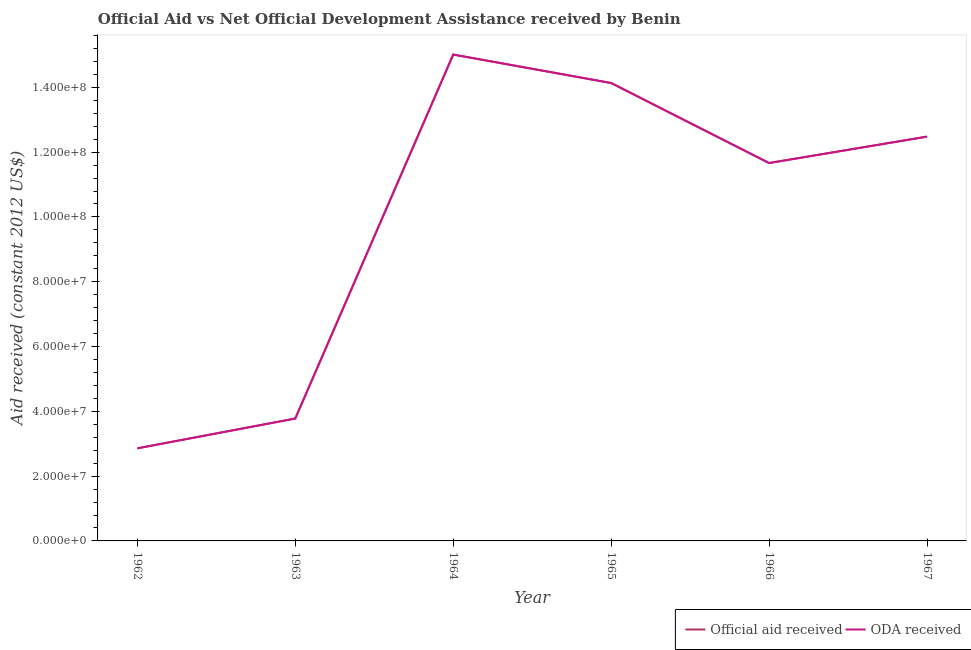What is the oda received in 1962?
Provide a succinct answer. 2.86e+07. Across all years, what is the maximum oda received?
Offer a terse response. 1.50e+08. Across all years, what is the minimum official aid received?
Your answer should be compact. 2.86e+07. In which year was the official aid received maximum?
Give a very brief answer. 1964. In which year was the oda received minimum?
Provide a short and direct response. 1962. What is the total oda received in the graph?
Provide a short and direct response. 5.99e+08. What is the difference between the official aid received in 1962 and that in 1965?
Provide a succinct answer. -1.13e+08. What is the difference between the oda received in 1964 and the official aid received in 1962?
Give a very brief answer. 1.22e+08. What is the average official aid received per year?
Offer a very short reply. 9.99e+07. In the year 1962, what is the difference between the official aid received and oda received?
Ensure brevity in your answer.  0. In how many years, is the oda received greater than 60000000 US$?
Give a very brief answer. 4. What is the ratio of the official aid received in 1964 to that in 1966?
Provide a short and direct response. 1.29. Is the difference between the oda received in 1963 and 1966 greater than the difference between the official aid received in 1963 and 1966?
Offer a terse response. No. What is the difference between the highest and the second highest oda received?
Make the answer very short. 8.78e+06. What is the difference between the highest and the lowest oda received?
Keep it short and to the point. 1.22e+08. In how many years, is the official aid received greater than the average official aid received taken over all years?
Offer a very short reply. 4. Is the sum of the oda received in 1964 and 1965 greater than the maximum official aid received across all years?
Make the answer very short. Yes. How many lines are there?
Keep it short and to the point. 2. What is the difference between two consecutive major ticks on the Y-axis?
Your answer should be compact. 2.00e+07. Does the graph contain grids?
Provide a short and direct response. No. What is the title of the graph?
Offer a very short reply. Official Aid vs Net Official Development Assistance received by Benin . Does "Canada" appear as one of the legend labels in the graph?
Make the answer very short. No. What is the label or title of the Y-axis?
Offer a very short reply. Aid received (constant 2012 US$). What is the Aid received (constant 2012 US$) of Official aid received in 1962?
Your response must be concise. 2.86e+07. What is the Aid received (constant 2012 US$) in ODA received in 1962?
Make the answer very short. 2.86e+07. What is the Aid received (constant 2012 US$) of Official aid received in 1963?
Provide a short and direct response. 3.78e+07. What is the Aid received (constant 2012 US$) in ODA received in 1963?
Keep it short and to the point. 3.78e+07. What is the Aid received (constant 2012 US$) in Official aid received in 1964?
Offer a very short reply. 1.50e+08. What is the Aid received (constant 2012 US$) in ODA received in 1964?
Ensure brevity in your answer.  1.50e+08. What is the Aid received (constant 2012 US$) of Official aid received in 1965?
Your answer should be compact. 1.41e+08. What is the Aid received (constant 2012 US$) of ODA received in 1965?
Your answer should be compact. 1.41e+08. What is the Aid received (constant 2012 US$) of Official aid received in 1966?
Your answer should be very brief. 1.17e+08. What is the Aid received (constant 2012 US$) in ODA received in 1966?
Provide a short and direct response. 1.17e+08. What is the Aid received (constant 2012 US$) in Official aid received in 1967?
Keep it short and to the point. 1.25e+08. What is the Aid received (constant 2012 US$) in ODA received in 1967?
Your response must be concise. 1.25e+08. Across all years, what is the maximum Aid received (constant 2012 US$) of Official aid received?
Your answer should be very brief. 1.50e+08. Across all years, what is the maximum Aid received (constant 2012 US$) of ODA received?
Offer a terse response. 1.50e+08. Across all years, what is the minimum Aid received (constant 2012 US$) in Official aid received?
Your answer should be very brief. 2.86e+07. Across all years, what is the minimum Aid received (constant 2012 US$) in ODA received?
Offer a terse response. 2.86e+07. What is the total Aid received (constant 2012 US$) in Official aid received in the graph?
Give a very brief answer. 5.99e+08. What is the total Aid received (constant 2012 US$) in ODA received in the graph?
Provide a short and direct response. 5.99e+08. What is the difference between the Aid received (constant 2012 US$) in Official aid received in 1962 and that in 1963?
Your answer should be compact. -9.20e+06. What is the difference between the Aid received (constant 2012 US$) of ODA received in 1962 and that in 1963?
Your answer should be compact. -9.20e+06. What is the difference between the Aid received (constant 2012 US$) of Official aid received in 1962 and that in 1964?
Provide a short and direct response. -1.22e+08. What is the difference between the Aid received (constant 2012 US$) in ODA received in 1962 and that in 1964?
Keep it short and to the point. -1.22e+08. What is the difference between the Aid received (constant 2012 US$) in Official aid received in 1962 and that in 1965?
Ensure brevity in your answer.  -1.13e+08. What is the difference between the Aid received (constant 2012 US$) in ODA received in 1962 and that in 1965?
Provide a short and direct response. -1.13e+08. What is the difference between the Aid received (constant 2012 US$) of Official aid received in 1962 and that in 1966?
Your response must be concise. -8.81e+07. What is the difference between the Aid received (constant 2012 US$) of ODA received in 1962 and that in 1966?
Your answer should be very brief. -8.81e+07. What is the difference between the Aid received (constant 2012 US$) in Official aid received in 1962 and that in 1967?
Keep it short and to the point. -9.62e+07. What is the difference between the Aid received (constant 2012 US$) in ODA received in 1962 and that in 1967?
Your response must be concise. -9.62e+07. What is the difference between the Aid received (constant 2012 US$) of Official aid received in 1963 and that in 1964?
Ensure brevity in your answer.  -1.12e+08. What is the difference between the Aid received (constant 2012 US$) in ODA received in 1963 and that in 1964?
Your response must be concise. -1.12e+08. What is the difference between the Aid received (constant 2012 US$) of Official aid received in 1963 and that in 1965?
Your answer should be very brief. -1.04e+08. What is the difference between the Aid received (constant 2012 US$) of ODA received in 1963 and that in 1965?
Give a very brief answer. -1.04e+08. What is the difference between the Aid received (constant 2012 US$) of Official aid received in 1963 and that in 1966?
Offer a very short reply. -7.89e+07. What is the difference between the Aid received (constant 2012 US$) in ODA received in 1963 and that in 1966?
Your answer should be very brief. -7.89e+07. What is the difference between the Aid received (constant 2012 US$) of Official aid received in 1963 and that in 1967?
Your answer should be very brief. -8.70e+07. What is the difference between the Aid received (constant 2012 US$) in ODA received in 1963 and that in 1967?
Provide a short and direct response. -8.70e+07. What is the difference between the Aid received (constant 2012 US$) of Official aid received in 1964 and that in 1965?
Provide a succinct answer. 8.78e+06. What is the difference between the Aid received (constant 2012 US$) of ODA received in 1964 and that in 1965?
Keep it short and to the point. 8.78e+06. What is the difference between the Aid received (constant 2012 US$) in Official aid received in 1964 and that in 1966?
Provide a succinct answer. 3.35e+07. What is the difference between the Aid received (constant 2012 US$) of ODA received in 1964 and that in 1966?
Keep it short and to the point. 3.35e+07. What is the difference between the Aid received (constant 2012 US$) of Official aid received in 1964 and that in 1967?
Your response must be concise. 2.53e+07. What is the difference between the Aid received (constant 2012 US$) in ODA received in 1964 and that in 1967?
Give a very brief answer. 2.53e+07. What is the difference between the Aid received (constant 2012 US$) of Official aid received in 1965 and that in 1966?
Your response must be concise. 2.47e+07. What is the difference between the Aid received (constant 2012 US$) in ODA received in 1965 and that in 1966?
Your response must be concise. 2.47e+07. What is the difference between the Aid received (constant 2012 US$) in Official aid received in 1965 and that in 1967?
Your response must be concise. 1.66e+07. What is the difference between the Aid received (constant 2012 US$) of ODA received in 1965 and that in 1967?
Offer a very short reply. 1.66e+07. What is the difference between the Aid received (constant 2012 US$) of Official aid received in 1966 and that in 1967?
Your response must be concise. -8.15e+06. What is the difference between the Aid received (constant 2012 US$) in ODA received in 1966 and that in 1967?
Ensure brevity in your answer.  -8.15e+06. What is the difference between the Aid received (constant 2012 US$) of Official aid received in 1962 and the Aid received (constant 2012 US$) of ODA received in 1963?
Provide a succinct answer. -9.20e+06. What is the difference between the Aid received (constant 2012 US$) of Official aid received in 1962 and the Aid received (constant 2012 US$) of ODA received in 1964?
Offer a terse response. -1.22e+08. What is the difference between the Aid received (constant 2012 US$) in Official aid received in 1962 and the Aid received (constant 2012 US$) in ODA received in 1965?
Provide a short and direct response. -1.13e+08. What is the difference between the Aid received (constant 2012 US$) in Official aid received in 1962 and the Aid received (constant 2012 US$) in ODA received in 1966?
Offer a very short reply. -8.81e+07. What is the difference between the Aid received (constant 2012 US$) in Official aid received in 1962 and the Aid received (constant 2012 US$) in ODA received in 1967?
Keep it short and to the point. -9.62e+07. What is the difference between the Aid received (constant 2012 US$) in Official aid received in 1963 and the Aid received (constant 2012 US$) in ODA received in 1964?
Ensure brevity in your answer.  -1.12e+08. What is the difference between the Aid received (constant 2012 US$) of Official aid received in 1963 and the Aid received (constant 2012 US$) of ODA received in 1965?
Your response must be concise. -1.04e+08. What is the difference between the Aid received (constant 2012 US$) in Official aid received in 1963 and the Aid received (constant 2012 US$) in ODA received in 1966?
Ensure brevity in your answer.  -7.89e+07. What is the difference between the Aid received (constant 2012 US$) in Official aid received in 1963 and the Aid received (constant 2012 US$) in ODA received in 1967?
Ensure brevity in your answer.  -8.70e+07. What is the difference between the Aid received (constant 2012 US$) in Official aid received in 1964 and the Aid received (constant 2012 US$) in ODA received in 1965?
Offer a very short reply. 8.78e+06. What is the difference between the Aid received (constant 2012 US$) in Official aid received in 1964 and the Aid received (constant 2012 US$) in ODA received in 1966?
Offer a terse response. 3.35e+07. What is the difference between the Aid received (constant 2012 US$) of Official aid received in 1964 and the Aid received (constant 2012 US$) of ODA received in 1967?
Provide a short and direct response. 2.53e+07. What is the difference between the Aid received (constant 2012 US$) in Official aid received in 1965 and the Aid received (constant 2012 US$) in ODA received in 1966?
Ensure brevity in your answer.  2.47e+07. What is the difference between the Aid received (constant 2012 US$) in Official aid received in 1965 and the Aid received (constant 2012 US$) in ODA received in 1967?
Provide a short and direct response. 1.66e+07. What is the difference between the Aid received (constant 2012 US$) in Official aid received in 1966 and the Aid received (constant 2012 US$) in ODA received in 1967?
Ensure brevity in your answer.  -8.15e+06. What is the average Aid received (constant 2012 US$) of Official aid received per year?
Offer a very short reply. 9.99e+07. What is the average Aid received (constant 2012 US$) of ODA received per year?
Offer a very short reply. 9.99e+07. In the year 1962, what is the difference between the Aid received (constant 2012 US$) in Official aid received and Aid received (constant 2012 US$) in ODA received?
Keep it short and to the point. 0. In the year 1966, what is the difference between the Aid received (constant 2012 US$) in Official aid received and Aid received (constant 2012 US$) in ODA received?
Keep it short and to the point. 0. What is the ratio of the Aid received (constant 2012 US$) of Official aid received in 1962 to that in 1963?
Provide a succinct answer. 0.76. What is the ratio of the Aid received (constant 2012 US$) in ODA received in 1962 to that in 1963?
Offer a very short reply. 0.76. What is the ratio of the Aid received (constant 2012 US$) of Official aid received in 1962 to that in 1964?
Keep it short and to the point. 0.19. What is the ratio of the Aid received (constant 2012 US$) of ODA received in 1962 to that in 1964?
Make the answer very short. 0.19. What is the ratio of the Aid received (constant 2012 US$) of Official aid received in 1962 to that in 1965?
Give a very brief answer. 0.2. What is the ratio of the Aid received (constant 2012 US$) in ODA received in 1962 to that in 1965?
Your response must be concise. 0.2. What is the ratio of the Aid received (constant 2012 US$) in Official aid received in 1962 to that in 1966?
Provide a short and direct response. 0.24. What is the ratio of the Aid received (constant 2012 US$) in ODA received in 1962 to that in 1966?
Make the answer very short. 0.24. What is the ratio of the Aid received (constant 2012 US$) in Official aid received in 1962 to that in 1967?
Ensure brevity in your answer.  0.23. What is the ratio of the Aid received (constant 2012 US$) of ODA received in 1962 to that in 1967?
Keep it short and to the point. 0.23. What is the ratio of the Aid received (constant 2012 US$) in Official aid received in 1963 to that in 1964?
Provide a succinct answer. 0.25. What is the ratio of the Aid received (constant 2012 US$) in ODA received in 1963 to that in 1964?
Give a very brief answer. 0.25. What is the ratio of the Aid received (constant 2012 US$) of Official aid received in 1963 to that in 1965?
Offer a very short reply. 0.27. What is the ratio of the Aid received (constant 2012 US$) in ODA received in 1963 to that in 1965?
Your answer should be very brief. 0.27. What is the ratio of the Aid received (constant 2012 US$) in Official aid received in 1963 to that in 1966?
Your response must be concise. 0.32. What is the ratio of the Aid received (constant 2012 US$) in ODA received in 1963 to that in 1966?
Keep it short and to the point. 0.32. What is the ratio of the Aid received (constant 2012 US$) in Official aid received in 1963 to that in 1967?
Provide a short and direct response. 0.3. What is the ratio of the Aid received (constant 2012 US$) of ODA received in 1963 to that in 1967?
Keep it short and to the point. 0.3. What is the ratio of the Aid received (constant 2012 US$) in Official aid received in 1964 to that in 1965?
Offer a terse response. 1.06. What is the ratio of the Aid received (constant 2012 US$) of ODA received in 1964 to that in 1965?
Give a very brief answer. 1.06. What is the ratio of the Aid received (constant 2012 US$) in Official aid received in 1964 to that in 1966?
Provide a succinct answer. 1.29. What is the ratio of the Aid received (constant 2012 US$) of ODA received in 1964 to that in 1966?
Your response must be concise. 1.29. What is the ratio of the Aid received (constant 2012 US$) in Official aid received in 1964 to that in 1967?
Your answer should be compact. 1.2. What is the ratio of the Aid received (constant 2012 US$) in ODA received in 1964 to that in 1967?
Ensure brevity in your answer.  1.2. What is the ratio of the Aid received (constant 2012 US$) in Official aid received in 1965 to that in 1966?
Ensure brevity in your answer.  1.21. What is the ratio of the Aid received (constant 2012 US$) of ODA received in 1965 to that in 1966?
Your answer should be very brief. 1.21. What is the ratio of the Aid received (constant 2012 US$) in Official aid received in 1965 to that in 1967?
Ensure brevity in your answer.  1.13. What is the ratio of the Aid received (constant 2012 US$) in ODA received in 1965 to that in 1967?
Provide a succinct answer. 1.13. What is the ratio of the Aid received (constant 2012 US$) of Official aid received in 1966 to that in 1967?
Keep it short and to the point. 0.93. What is the ratio of the Aid received (constant 2012 US$) in ODA received in 1966 to that in 1967?
Your answer should be very brief. 0.93. What is the difference between the highest and the second highest Aid received (constant 2012 US$) in Official aid received?
Provide a short and direct response. 8.78e+06. What is the difference between the highest and the second highest Aid received (constant 2012 US$) of ODA received?
Keep it short and to the point. 8.78e+06. What is the difference between the highest and the lowest Aid received (constant 2012 US$) in Official aid received?
Ensure brevity in your answer.  1.22e+08. What is the difference between the highest and the lowest Aid received (constant 2012 US$) of ODA received?
Offer a very short reply. 1.22e+08. 